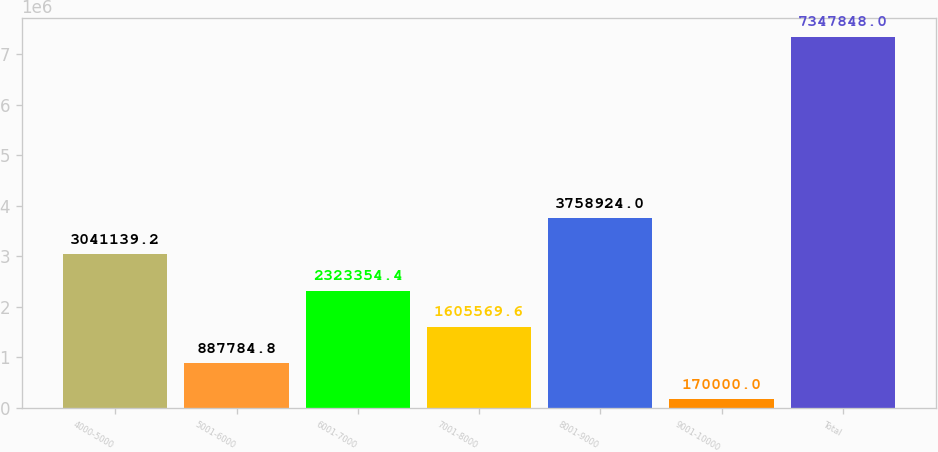Convert chart. <chart><loc_0><loc_0><loc_500><loc_500><bar_chart><fcel>4000-5000<fcel>5001-6000<fcel>6001-7000<fcel>7001-8000<fcel>8001-9000<fcel>9001-10000<fcel>Total<nl><fcel>3.04114e+06<fcel>887785<fcel>2.32335e+06<fcel>1.60557e+06<fcel>3.75892e+06<fcel>170000<fcel>7.34785e+06<nl></chart> 